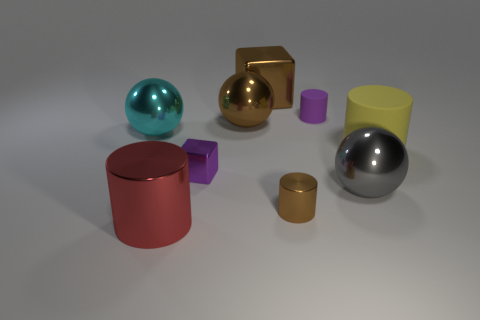Add 1 large matte objects. How many objects exist? 10 Subtract all blocks. How many objects are left? 7 Add 8 big shiny cylinders. How many big shiny cylinders are left? 9 Add 2 large gray rubber things. How many large gray rubber things exist? 2 Subtract 0 blue cylinders. How many objects are left? 9 Subtract all blue cylinders. Subtract all big cylinders. How many objects are left? 7 